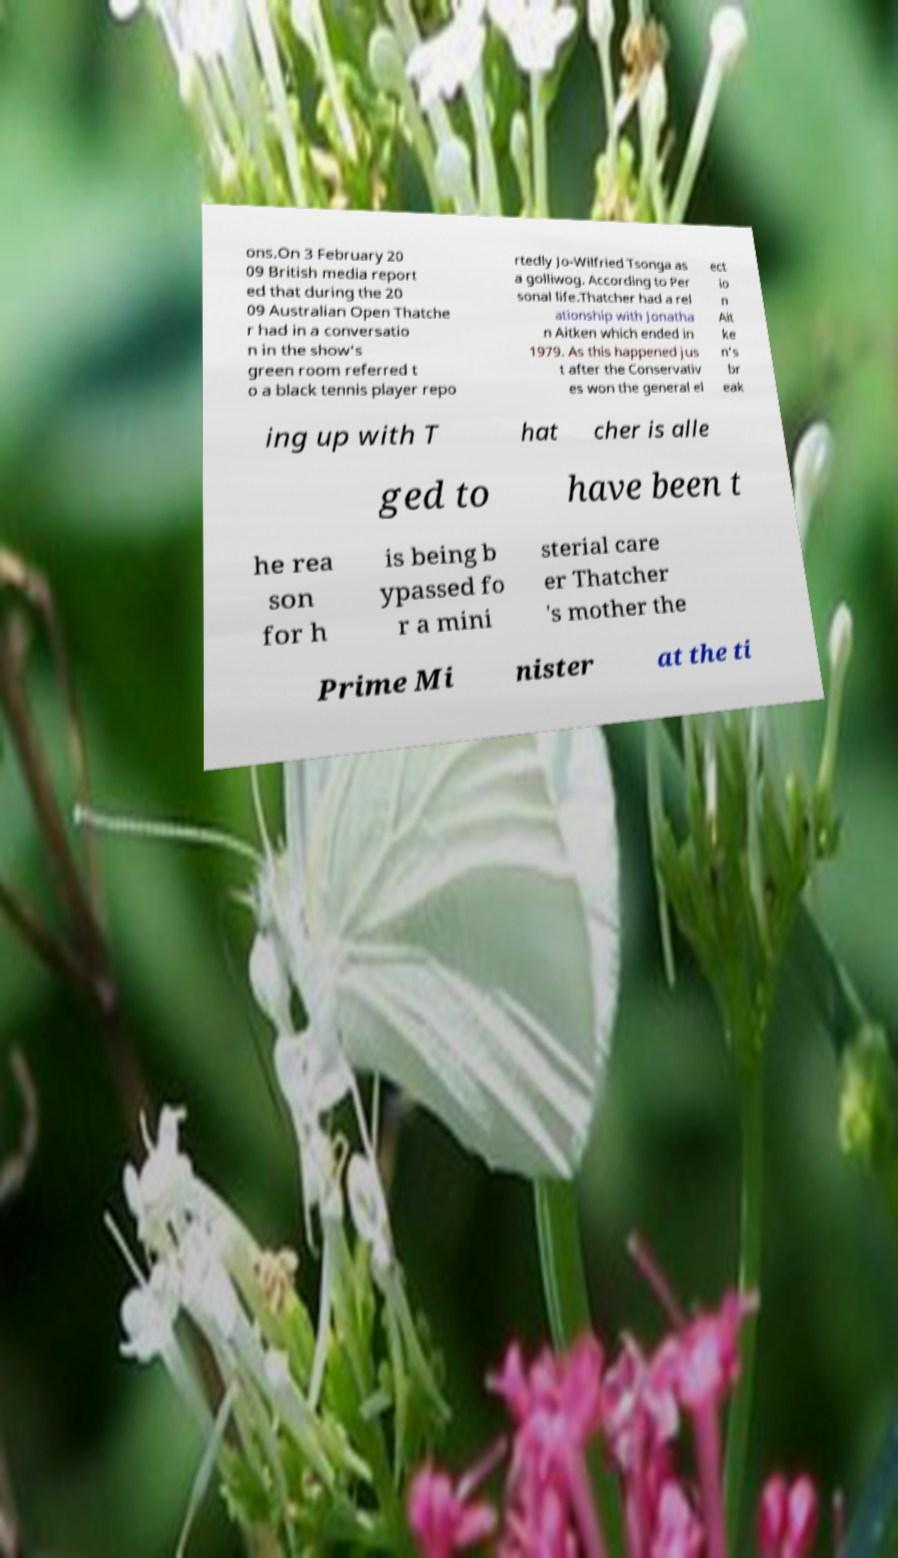Please identify and transcribe the text found in this image. ons.On 3 February 20 09 British media report ed that during the 20 09 Australian Open Thatche r had in a conversatio n in the show's green room referred t o a black tennis player repo rtedly Jo-Wilfried Tsonga as a golliwog. According to Per sonal life.Thatcher had a rel ationship with Jonatha n Aitken which ended in 1979. As this happened jus t after the Conservativ es won the general el ect io n Ait ke n's br eak ing up with T hat cher is alle ged to have been t he rea son for h is being b ypassed fo r a mini sterial care er Thatcher 's mother the Prime Mi nister at the ti 